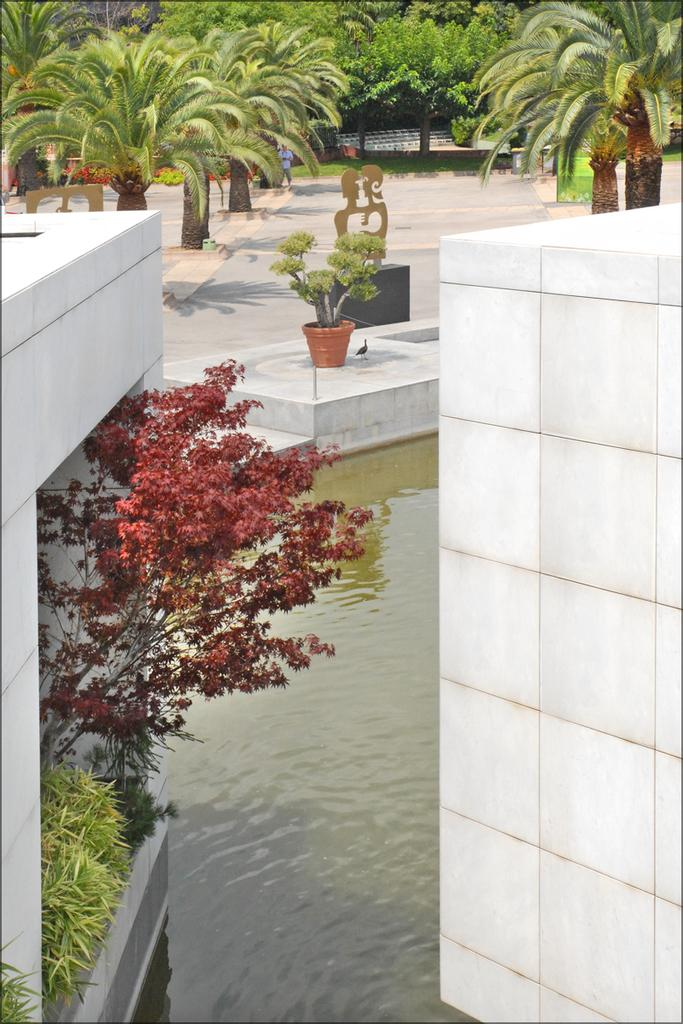What type of vegetation can be seen in the image? There are plants in the image. What is located in the middle of the image? There is a pond in the middle of the image. What is on the right side of the image? There is a wall on the right side of the image. What can be seen at the top of the image? There are trees at the top of the image. How many legs can be seen on the plants in the image? Plants do not have legs, so this question cannot be answered. Is there a fight happening in the image? There is no indication of a fight in the image; it features plants, a pond, a wall, and trees. 